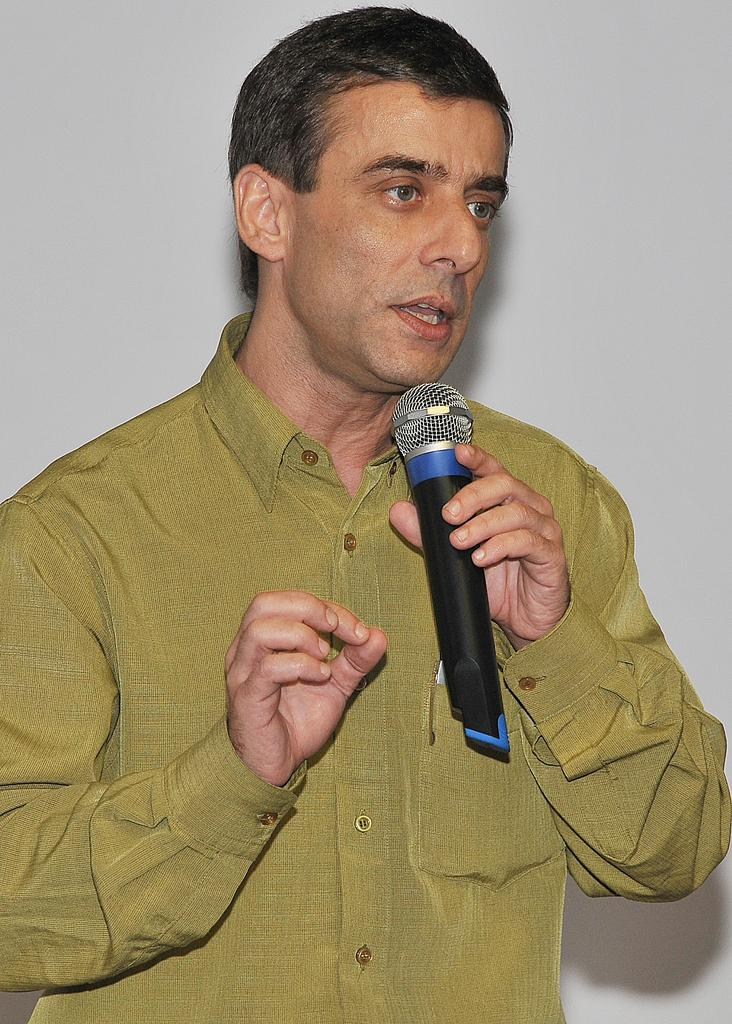Who is the main subject in the image? There is a man in the center of the image. What is the man doing in the image? The man is standing and holding a mic in his hand. What can be seen in the background of the image? There is a wall in the background of the image. What type of doll is sitting on the wall in the image? There is no doll present in the image; it only features a man standing with a mic and a wall in the background. 